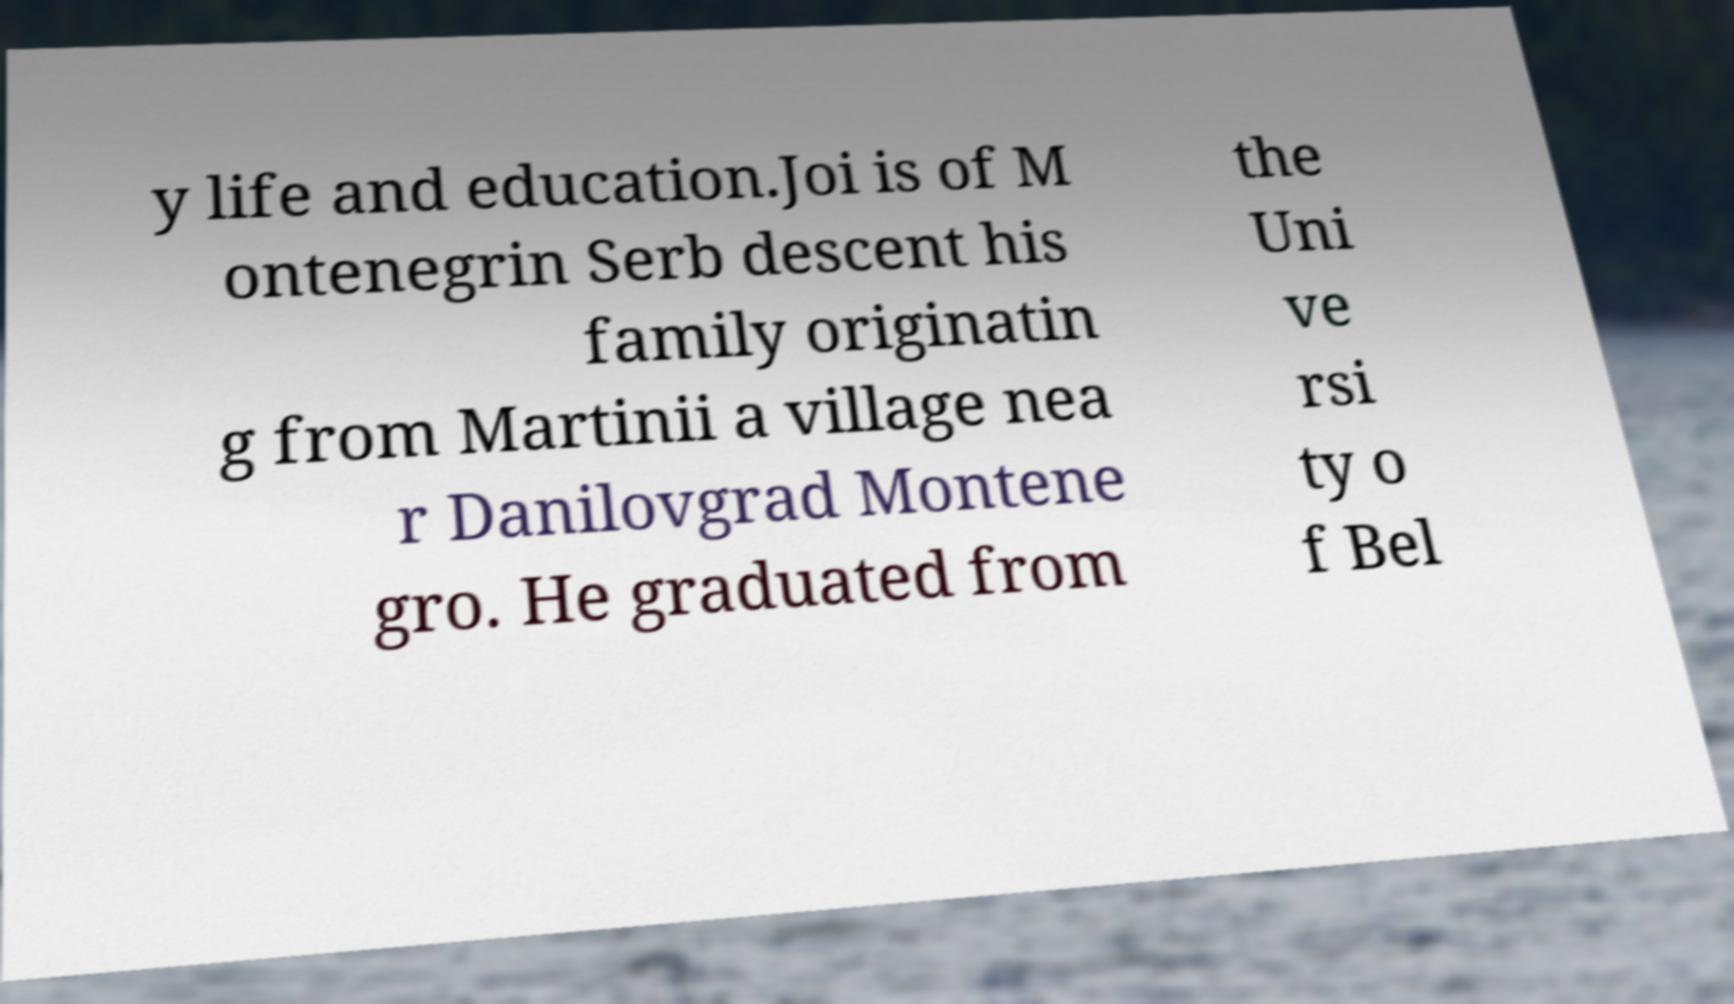For documentation purposes, I need the text within this image transcribed. Could you provide that? y life and education.Joi is of M ontenegrin Serb descent his family originatin g from Martinii a village nea r Danilovgrad Montene gro. He graduated from the Uni ve rsi ty o f Bel 